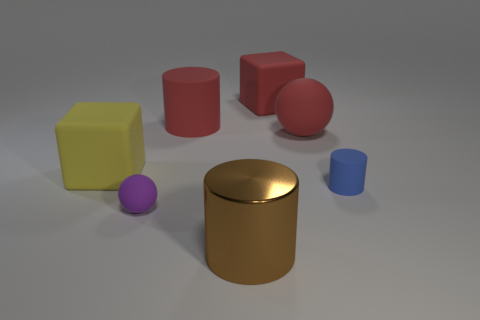Add 1 large red things. How many objects exist? 8 Subtract all cylinders. How many objects are left? 4 Subtract all purple spheres. Subtract all large brown objects. How many objects are left? 5 Add 4 big red matte spheres. How many big red matte spheres are left? 5 Add 6 small metal things. How many small metal things exist? 6 Subtract 0 blue cubes. How many objects are left? 7 